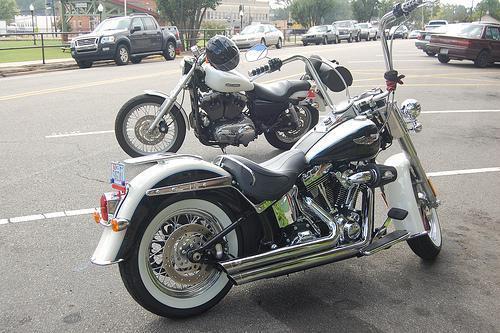How many helmets are pictured?
Give a very brief answer. 1. 